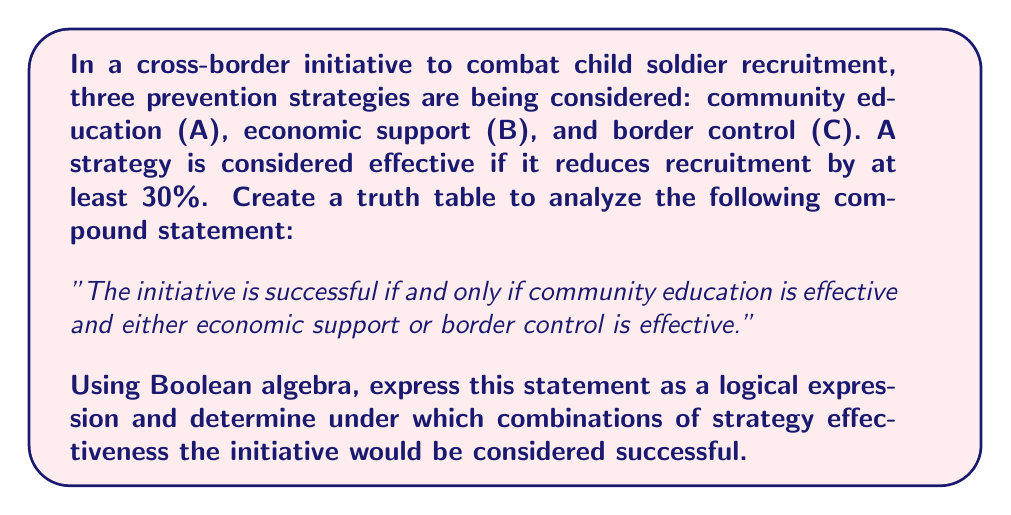Could you help me with this problem? Let's approach this step-by-step:

1) First, let's define our variables:
   A: Community education is effective
   B: Economic support is effective
   C: Border control is effective

2) The statement can be expressed in Boolean algebra as:
   $S \iff A \wedge (B \vee C)$
   Where S represents the success of the initiative.

3) Now, let's create a truth table:

   | A | B | C | B ∨ C | A ∧ (B ∨ C) | S |
   |---|---|---|-------|-------------|---|
   | 0 | 0 | 0 |   0   |      0      | 0 |
   | 0 | 0 | 1 |   1   |      0      | 0 |
   | 0 | 1 | 0 |   1   |      0      | 0 |
   | 0 | 1 | 1 |   1   |      0      | 0 |
   | 1 | 0 | 0 |   0   |      0      | 0 |
   | 1 | 0 | 1 |   1   |      1      | 1 |
   | 1 | 1 | 0 |   1   |      1      | 1 |
   | 1 | 1 | 1 |   1   |      1      | 1 |

4) From the truth table, we can see that the initiative is successful (S = 1) in three cases:
   - When A = 1, B = 0, C = 1
   - When A = 1, B = 1, C = 0
   - When A = 1, B = 1, C = 1

5) This can be expressed as a Boolean expression:
   $S = A \wedge (B \vee C)$

6) In terms of our strategies, this means the initiative is successful when:
   - Community education is effective AND either economic support OR border control (or both) is effective.
Answer: $S = A \wedge (B \vee C)$ 